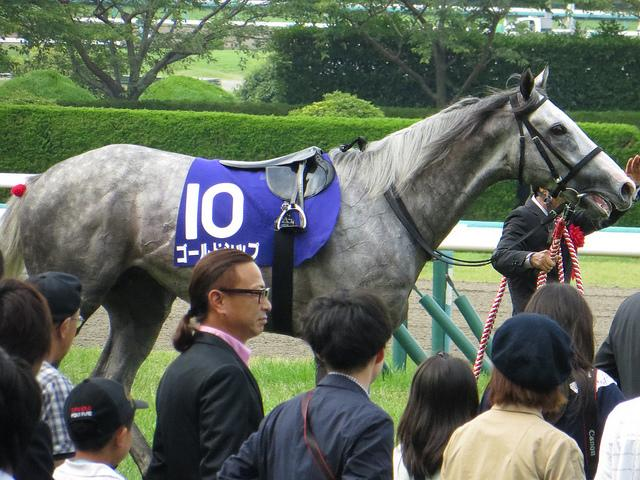What does the number ten indicate? horse number 